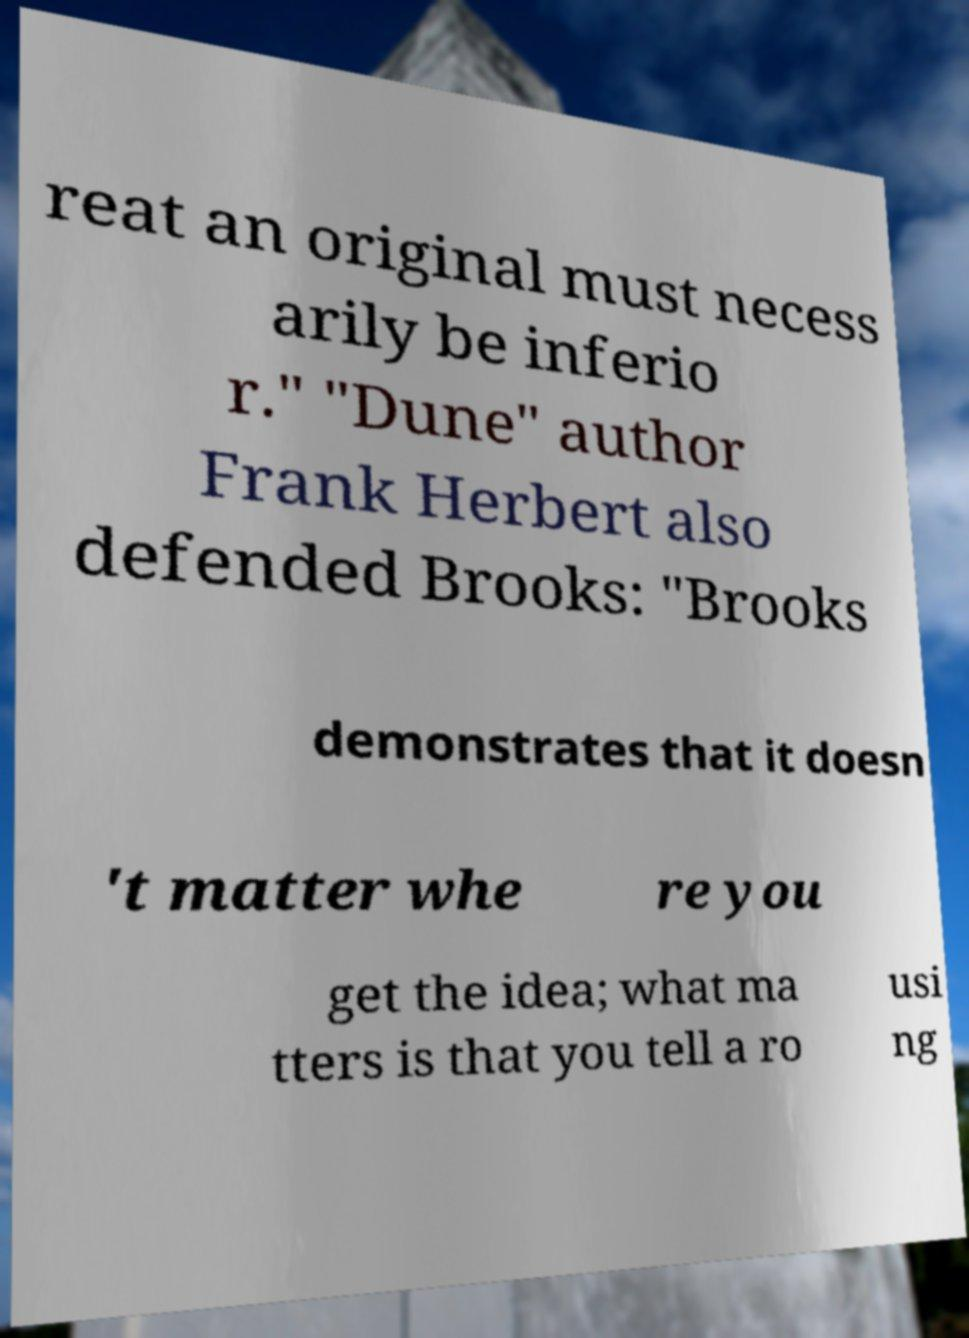For documentation purposes, I need the text within this image transcribed. Could you provide that? reat an original must necess arily be inferio r." "Dune" author Frank Herbert also defended Brooks: "Brooks demonstrates that it doesn 't matter whe re you get the idea; what ma tters is that you tell a ro usi ng 